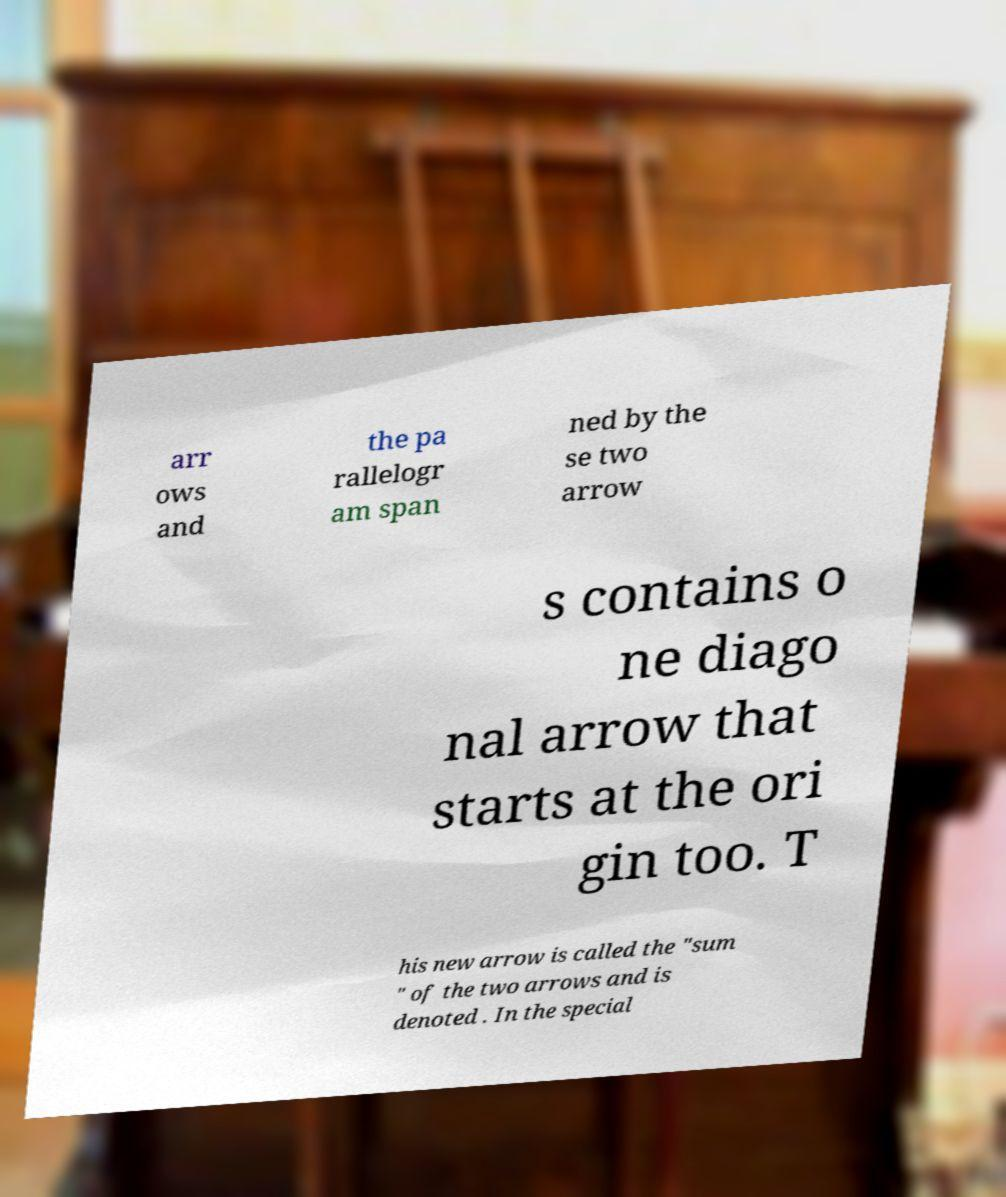Can you accurately transcribe the text from the provided image for me? arr ows and the pa rallelogr am span ned by the se two arrow s contains o ne diago nal arrow that starts at the ori gin too. T his new arrow is called the "sum " of the two arrows and is denoted . In the special 